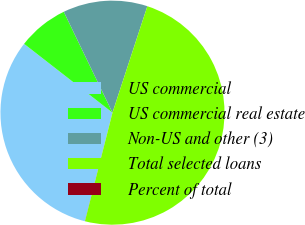Convert chart. <chart><loc_0><loc_0><loc_500><loc_500><pie_chart><fcel>US commercial<fcel>US commercial real estate<fcel>Non-US and other (3)<fcel>Total selected loans<fcel>Percent of total<nl><fcel>31.57%<fcel>7.31%<fcel>12.2%<fcel>48.91%<fcel>0.01%<nl></chart> 